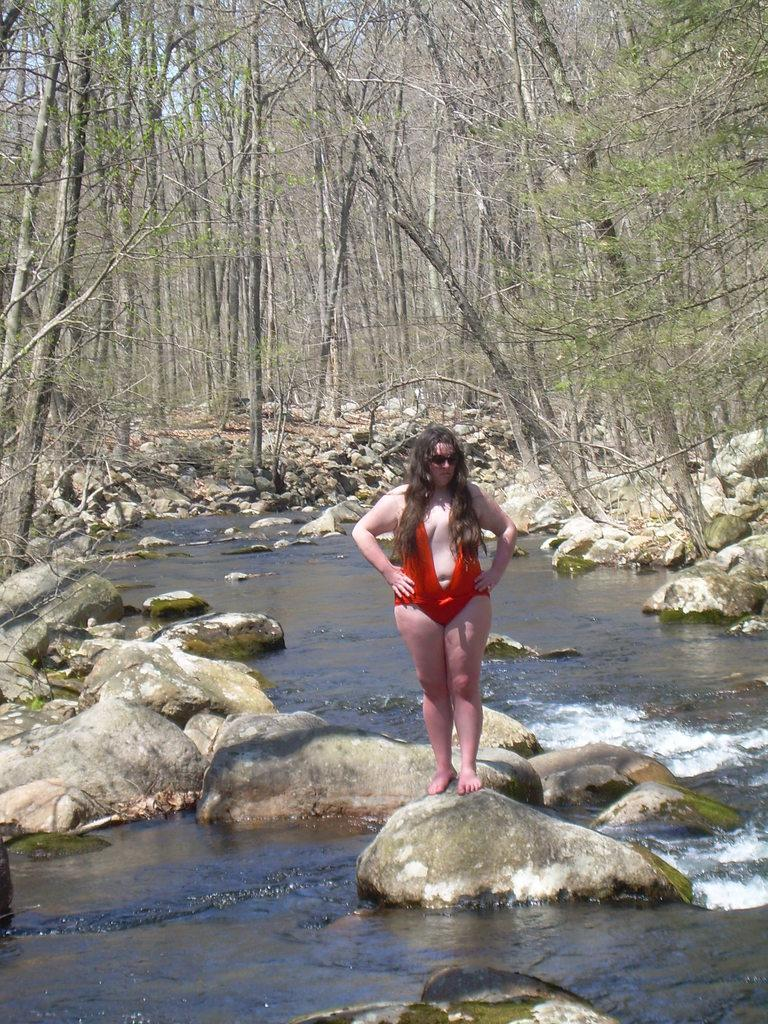What is the woman in the image standing on? The woman is standing on a rock in the image. What can be seen in the image besides the woman and the rock? There is water, rocks, trees, and the sky visible in the image. What type of natural environment is depicted in the image? The image depicts a natural environment with water, rocks, and trees. What is visible in the background of the image? The sky is visible in the background of the image. What type of ticket is the woman holding in the image? There is no ticket visible in the image; the woman is standing on a rock with no apparent ticket in her hand. 